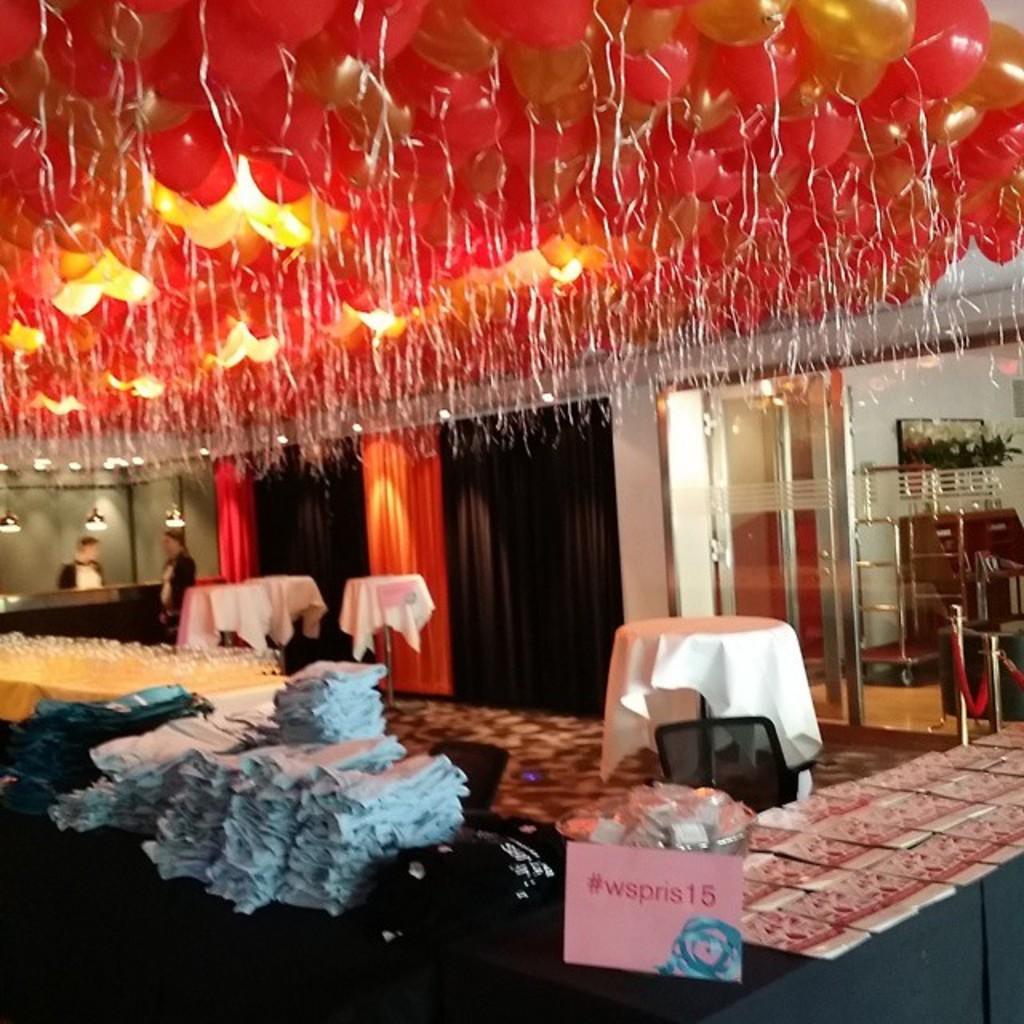Could you give a brief overview of what you see in this image? In the image there are clothes,glasses and books on a table with a cloth and over the ceiling there are many balloons and lights, this seems to be clicked inside a banquet hall, in the back there are two waiters standing, on the right side there is glass wall with tables in front of it and furniture behind it. 